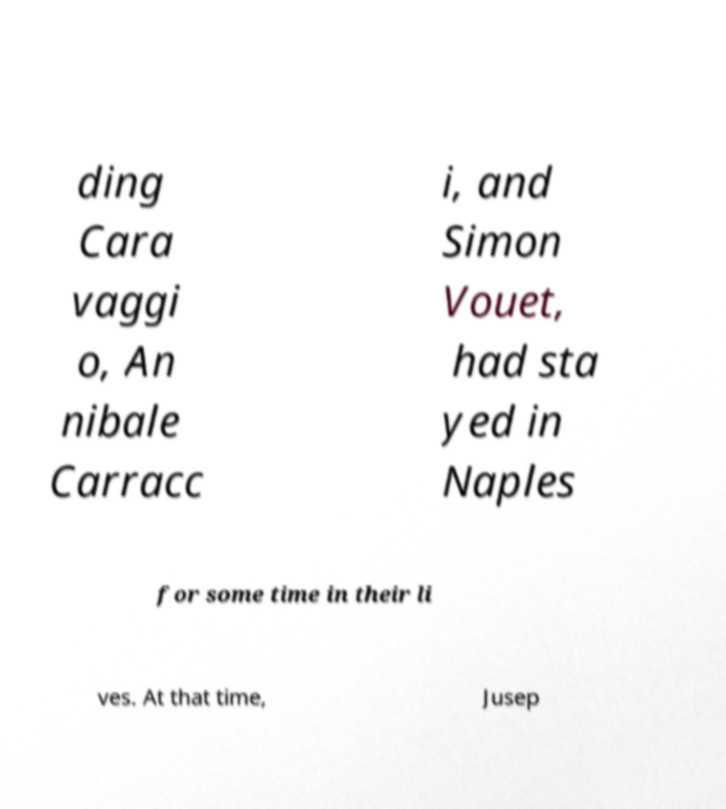What messages or text are displayed in this image? I need them in a readable, typed format. ding Cara vaggi o, An nibale Carracc i, and Simon Vouet, had sta yed in Naples for some time in their li ves. At that time, Jusep 